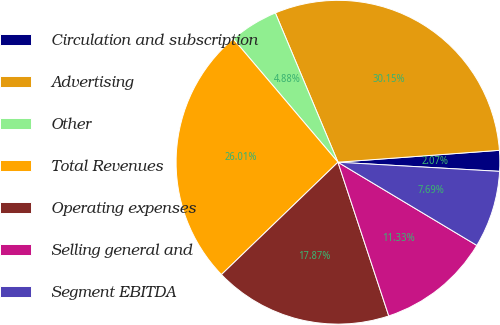Convert chart. <chart><loc_0><loc_0><loc_500><loc_500><pie_chart><fcel>Circulation and subscription<fcel>Advertising<fcel>Other<fcel>Total Revenues<fcel>Operating expenses<fcel>Selling general and<fcel>Segment EBITDA<nl><fcel>2.07%<fcel>30.15%<fcel>4.88%<fcel>26.01%<fcel>17.87%<fcel>11.33%<fcel>7.69%<nl></chart> 